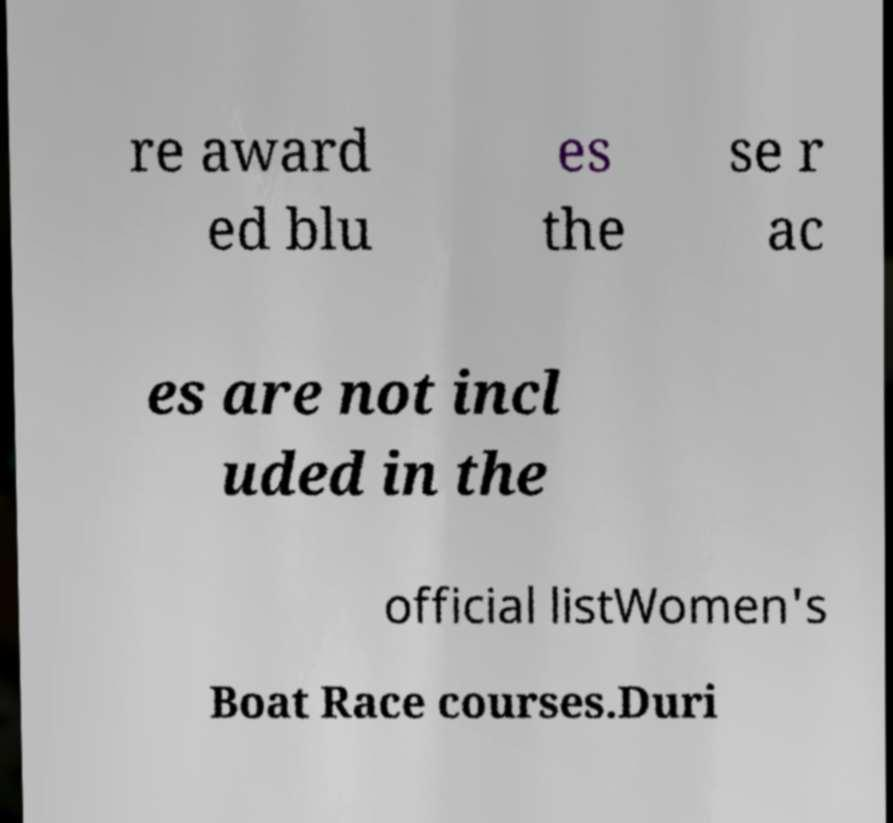I need the written content from this picture converted into text. Can you do that? re award ed blu es the se r ac es are not incl uded in the official listWomen's Boat Race courses.Duri 